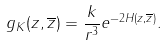Convert formula to latex. <formula><loc_0><loc_0><loc_500><loc_500>g _ { K } ( z , \overline { z } ) = \frac { k } { r ^ { 3 } } e ^ { - 2 H ( z , \overline { z } ) } .</formula> 